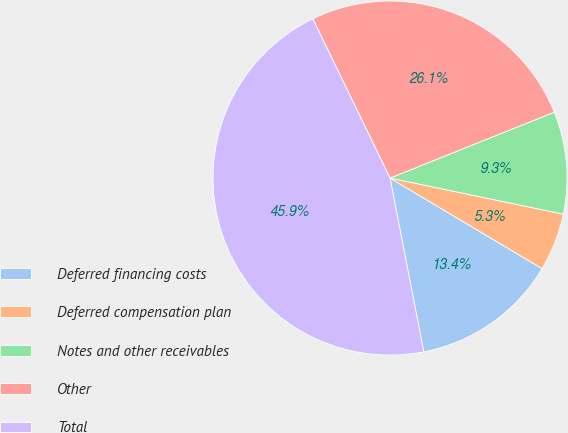Convert chart. <chart><loc_0><loc_0><loc_500><loc_500><pie_chart><fcel>Deferred financing costs<fcel>Deferred compensation plan<fcel>Notes and other receivables<fcel>Other<fcel>Total<nl><fcel>13.4%<fcel>5.28%<fcel>9.34%<fcel>26.11%<fcel>45.87%<nl></chart> 